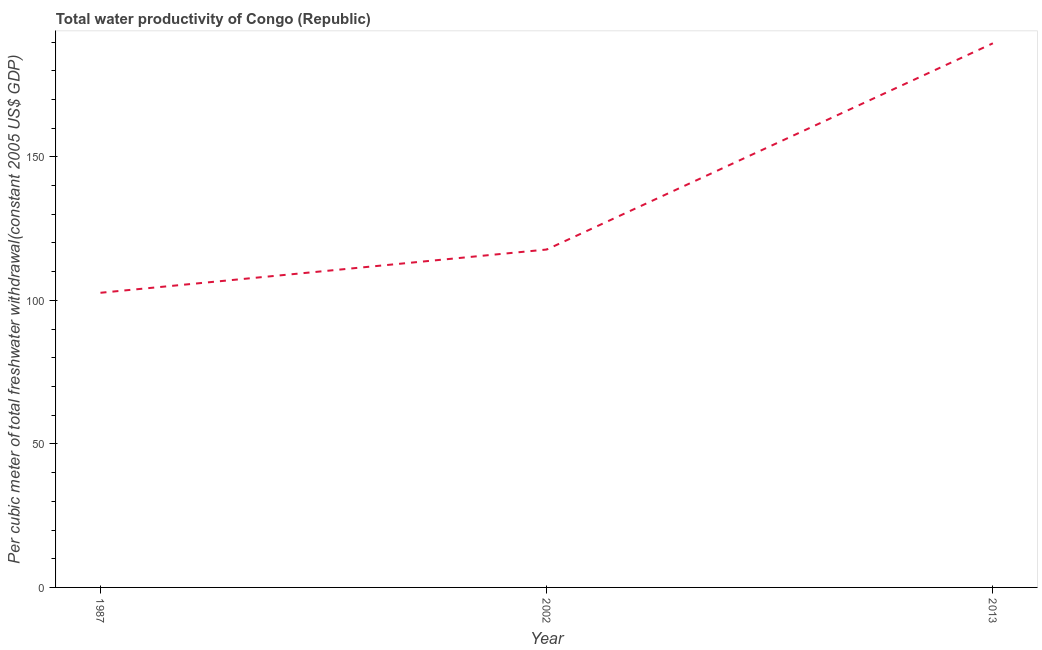What is the total water productivity in 1987?
Ensure brevity in your answer.  102.65. Across all years, what is the maximum total water productivity?
Provide a short and direct response. 189.56. Across all years, what is the minimum total water productivity?
Make the answer very short. 102.65. In which year was the total water productivity maximum?
Keep it short and to the point. 2013. In which year was the total water productivity minimum?
Provide a succinct answer. 1987. What is the sum of the total water productivity?
Provide a short and direct response. 409.93. What is the difference between the total water productivity in 2002 and 2013?
Keep it short and to the point. -71.85. What is the average total water productivity per year?
Your answer should be very brief. 136.64. What is the median total water productivity?
Offer a very short reply. 117.72. Do a majority of the years between 1987 and 2002 (inclusive) have total water productivity greater than 10 US$?
Offer a terse response. Yes. What is the ratio of the total water productivity in 2002 to that in 2013?
Make the answer very short. 0.62. Is the total water productivity in 2002 less than that in 2013?
Your answer should be very brief. Yes. Is the difference between the total water productivity in 1987 and 2013 greater than the difference between any two years?
Make the answer very short. Yes. What is the difference between the highest and the second highest total water productivity?
Your answer should be very brief. 71.85. Is the sum of the total water productivity in 1987 and 2013 greater than the maximum total water productivity across all years?
Your answer should be very brief. Yes. What is the difference between the highest and the lowest total water productivity?
Offer a terse response. 86.91. What is the difference between two consecutive major ticks on the Y-axis?
Provide a succinct answer. 50. Are the values on the major ticks of Y-axis written in scientific E-notation?
Give a very brief answer. No. Does the graph contain grids?
Your answer should be compact. No. What is the title of the graph?
Ensure brevity in your answer.  Total water productivity of Congo (Republic). What is the label or title of the Y-axis?
Your answer should be very brief. Per cubic meter of total freshwater withdrawal(constant 2005 US$ GDP). What is the Per cubic meter of total freshwater withdrawal(constant 2005 US$ GDP) of 1987?
Offer a terse response. 102.65. What is the Per cubic meter of total freshwater withdrawal(constant 2005 US$ GDP) of 2002?
Offer a terse response. 117.72. What is the Per cubic meter of total freshwater withdrawal(constant 2005 US$ GDP) of 2013?
Provide a succinct answer. 189.56. What is the difference between the Per cubic meter of total freshwater withdrawal(constant 2005 US$ GDP) in 1987 and 2002?
Provide a short and direct response. -15.07. What is the difference between the Per cubic meter of total freshwater withdrawal(constant 2005 US$ GDP) in 1987 and 2013?
Provide a succinct answer. -86.91. What is the difference between the Per cubic meter of total freshwater withdrawal(constant 2005 US$ GDP) in 2002 and 2013?
Your answer should be compact. -71.85. What is the ratio of the Per cubic meter of total freshwater withdrawal(constant 2005 US$ GDP) in 1987 to that in 2002?
Provide a short and direct response. 0.87. What is the ratio of the Per cubic meter of total freshwater withdrawal(constant 2005 US$ GDP) in 1987 to that in 2013?
Ensure brevity in your answer.  0.54. What is the ratio of the Per cubic meter of total freshwater withdrawal(constant 2005 US$ GDP) in 2002 to that in 2013?
Ensure brevity in your answer.  0.62. 